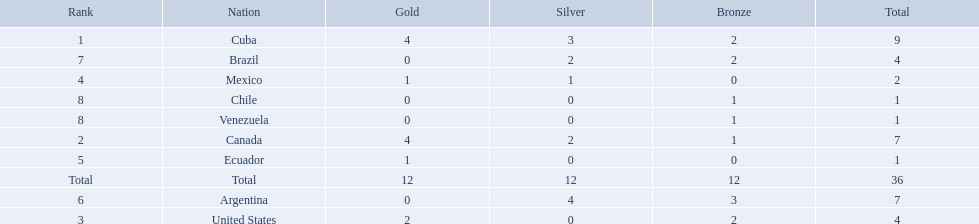Which nations won a gold medal in canoeing in the 2011 pan american games? Cuba, Canada, United States, Mexico, Ecuador. Which of these did not win any silver medals? United States. Which countries have won gold medals? Cuba, Canada, United States, Mexico, Ecuador. Of these countries, which ones have never won silver or bronze medals? United States, Ecuador. Of the two nations listed previously, which one has only won a gold medal? Ecuador. 